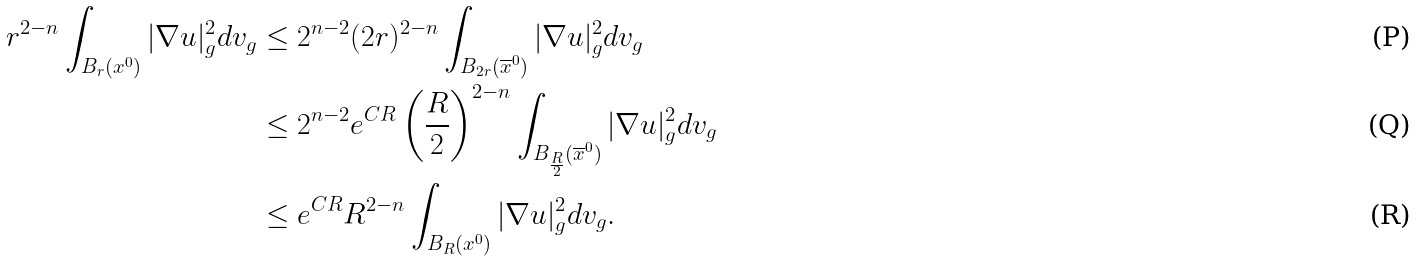Convert formula to latex. <formula><loc_0><loc_0><loc_500><loc_500>r ^ { 2 - n } \int _ { B _ { r } ( x ^ { 0 } ) } | \nabla { u } | _ { g } ^ { 2 } d v _ { g } & \leq 2 ^ { n - 2 } ( 2 r ) ^ { 2 - n } \int _ { B _ { 2 r } ( \overline { x } ^ { 0 } ) } | \nabla { u } | _ { g } ^ { 2 } d v _ { g } \\ & \leq 2 ^ { n - 2 } e ^ { C R } \left ( \frac { R } { 2 } \right ) ^ { 2 - n } \int _ { B _ { \frac { R } { 2 } } ( \overline { x } ^ { 0 } ) } | \nabla { u } | _ { g } ^ { 2 } d v _ { g } \\ & \leq e ^ { C R } R ^ { 2 - n } \int _ { B _ { R } ( x ^ { 0 } ) } | \nabla { u } | _ { g } ^ { 2 } d v _ { g } .</formula> 